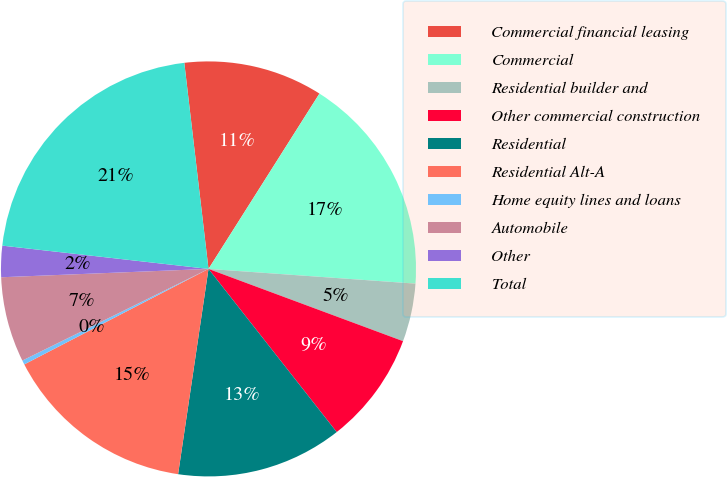<chart> <loc_0><loc_0><loc_500><loc_500><pie_chart><fcel>Commercial financial leasing<fcel>Commercial<fcel>Residential builder and<fcel>Other commercial construction<fcel>Residential<fcel>Residential Alt-A<fcel>Home equity lines and loans<fcel>Automobile<fcel>Other<fcel>Total<nl><fcel>10.84%<fcel>17.15%<fcel>4.53%<fcel>8.74%<fcel>12.94%<fcel>15.05%<fcel>0.33%<fcel>6.64%<fcel>2.43%<fcel>21.35%<nl></chart> 